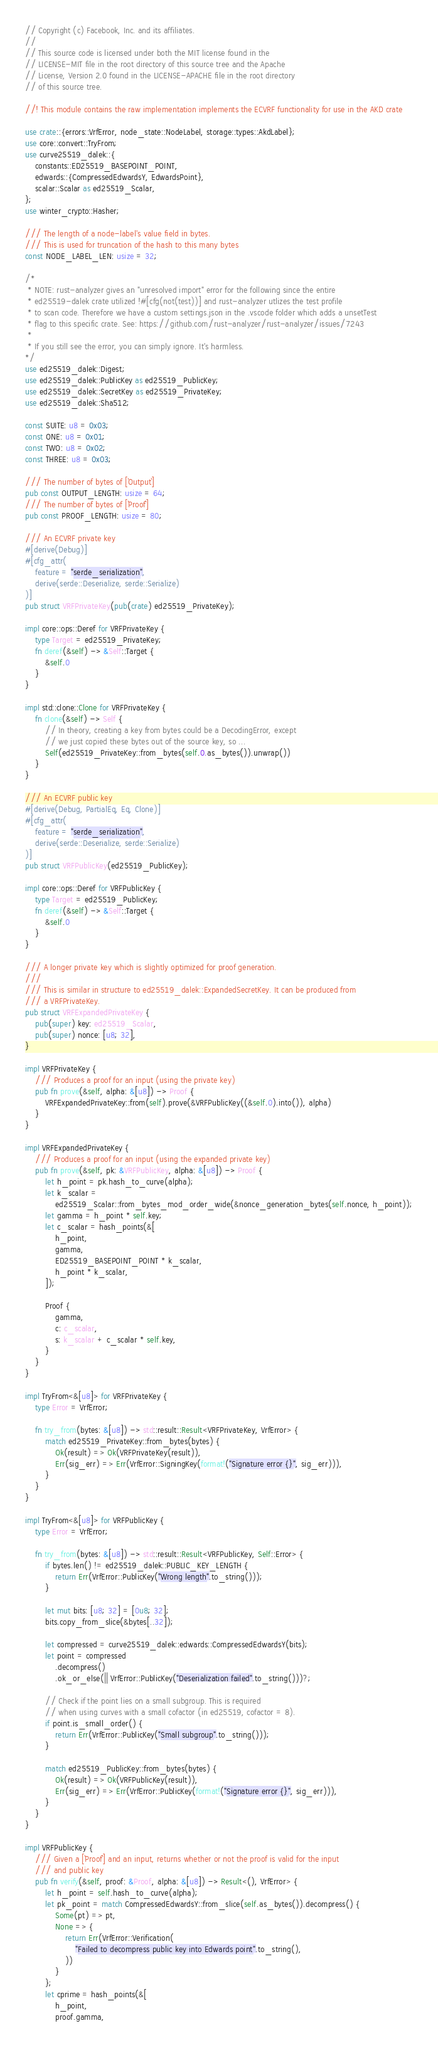Convert code to text. <code><loc_0><loc_0><loc_500><loc_500><_Rust_>// Copyright (c) Facebook, Inc. and its affiliates.
//
// This source code is licensed under both the MIT license found in the
// LICENSE-MIT file in the root directory of this source tree and the Apache
// License, Version 2.0 found in the LICENSE-APACHE file in the root directory
// of this source tree.

//! This module contains the raw implementation implements the ECVRF functionality for use in the AKD crate

use crate::{errors::VrfError, node_state::NodeLabel, storage::types::AkdLabel};
use core::convert::TryFrom;
use curve25519_dalek::{
    constants::ED25519_BASEPOINT_POINT,
    edwards::{CompressedEdwardsY, EdwardsPoint},
    scalar::Scalar as ed25519_Scalar,
};
use winter_crypto::Hasher;

/// The length of a node-label's value field in bytes.
/// This is used for truncation of the hash to this many bytes
const NODE_LABEL_LEN: usize = 32;

/*
 * NOTE: rust-analyzer gives an "unresolved import" error for the following since the entire
 * ed25519-dalek crate utilized !#[cfg(not(test))] and rust-analyzer utlizes the test profile
 * to scan code. Therefore we have a custom settings.json in the .vscode folder which adds a unsetTest
 * flag to this specific crate. See: https://github.com/rust-analyzer/rust-analyzer/issues/7243
 *
 * If you still see the error, you can simply ignore. It's harmless.
*/
use ed25519_dalek::Digest;
use ed25519_dalek::PublicKey as ed25519_PublicKey;
use ed25519_dalek::SecretKey as ed25519_PrivateKey;
use ed25519_dalek::Sha512;

const SUITE: u8 = 0x03;
const ONE: u8 = 0x01;
const TWO: u8 = 0x02;
const THREE: u8 = 0x03;

/// The number of bytes of [`Output`]
pub const OUTPUT_LENGTH: usize = 64;
/// The number of bytes of [`Proof`]
pub const PROOF_LENGTH: usize = 80;

/// An ECVRF private key
#[derive(Debug)]
#[cfg_attr(
    feature = "serde_serialization",
    derive(serde::Deserialize, serde::Serialize)
)]
pub struct VRFPrivateKey(pub(crate) ed25519_PrivateKey);

impl core::ops::Deref for VRFPrivateKey {
    type Target = ed25519_PrivateKey;
    fn deref(&self) -> &Self::Target {
        &self.0
    }
}

impl std::clone::Clone for VRFPrivateKey {
    fn clone(&self) -> Self {
        // In theory, creating a key from bytes could be a DecodingError, except
        // we just copied these bytes out of the source key, so ...
        Self(ed25519_PrivateKey::from_bytes(self.0.as_bytes()).unwrap())
    }
}

/// An ECVRF public key
#[derive(Debug, PartialEq, Eq, Clone)]
#[cfg_attr(
    feature = "serde_serialization",
    derive(serde::Deserialize, serde::Serialize)
)]
pub struct VRFPublicKey(ed25519_PublicKey);

impl core::ops::Deref for VRFPublicKey {
    type Target = ed25519_PublicKey;
    fn deref(&self) -> &Self::Target {
        &self.0
    }
}

/// A longer private key which is slightly optimized for proof generation.
///
/// This is similar in structure to ed25519_dalek::ExpandedSecretKey. It can be produced from
/// a VRFPrivateKey.
pub struct VRFExpandedPrivateKey {
    pub(super) key: ed25519_Scalar,
    pub(super) nonce: [u8; 32],
}

impl VRFPrivateKey {
    /// Produces a proof for an input (using the private key)
    pub fn prove(&self, alpha: &[u8]) -> Proof {
        VRFExpandedPrivateKey::from(self).prove(&VRFPublicKey((&self.0).into()), alpha)
    }
}

impl VRFExpandedPrivateKey {
    /// Produces a proof for an input (using the expanded private key)
    pub fn prove(&self, pk: &VRFPublicKey, alpha: &[u8]) -> Proof {
        let h_point = pk.hash_to_curve(alpha);
        let k_scalar =
            ed25519_Scalar::from_bytes_mod_order_wide(&nonce_generation_bytes(self.nonce, h_point));
        let gamma = h_point * self.key;
        let c_scalar = hash_points(&[
            h_point,
            gamma,
            ED25519_BASEPOINT_POINT * k_scalar,
            h_point * k_scalar,
        ]);

        Proof {
            gamma,
            c: c_scalar,
            s: k_scalar + c_scalar * self.key,
        }
    }
}

impl TryFrom<&[u8]> for VRFPrivateKey {
    type Error = VrfError;

    fn try_from(bytes: &[u8]) -> std::result::Result<VRFPrivateKey, VrfError> {
        match ed25519_PrivateKey::from_bytes(bytes) {
            Ok(result) => Ok(VRFPrivateKey(result)),
            Err(sig_err) => Err(VrfError::SigningKey(format!("Signature error {}", sig_err))),
        }
    }
}

impl TryFrom<&[u8]> for VRFPublicKey {
    type Error = VrfError;

    fn try_from(bytes: &[u8]) -> std::result::Result<VRFPublicKey, Self::Error> {
        if bytes.len() != ed25519_dalek::PUBLIC_KEY_LENGTH {
            return Err(VrfError::PublicKey("Wrong length".to_string()));
        }

        let mut bits: [u8; 32] = [0u8; 32];
        bits.copy_from_slice(&bytes[..32]);

        let compressed = curve25519_dalek::edwards::CompressedEdwardsY(bits);
        let point = compressed
            .decompress()
            .ok_or_else(|| VrfError::PublicKey("Deserialization failed".to_string()))?;

        // Check if the point lies on a small subgroup. This is required
        // when using curves with a small cofactor (in ed25519, cofactor = 8).
        if point.is_small_order() {
            return Err(VrfError::PublicKey("Small subgroup".to_string()));
        }

        match ed25519_PublicKey::from_bytes(bytes) {
            Ok(result) => Ok(VRFPublicKey(result)),
            Err(sig_err) => Err(VrfError::PublicKey(format!("Signature error {}", sig_err))),
        }
    }
}

impl VRFPublicKey {
    /// Given a [`Proof`] and an input, returns whether or not the proof is valid for the input
    /// and public key
    pub fn verify(&self, proof: &Proof, alpha: &[u8]) -> Result<(), VrfError> {
        let h_point = self.hash_to_curve(alpha);
        let pk_point = match CompressedEdwardsY::from_slice(self.as_bytes()).decompress() {
            Some(pt) => pt,
            None => {
                return Err(VrfError::Verification(
                    "Failed to decompress public key into Edwards point".to_string(),
                ))
            }
        };
        let cprime = hash_points(&[
            h_point,
            proof.gamma,</code> 